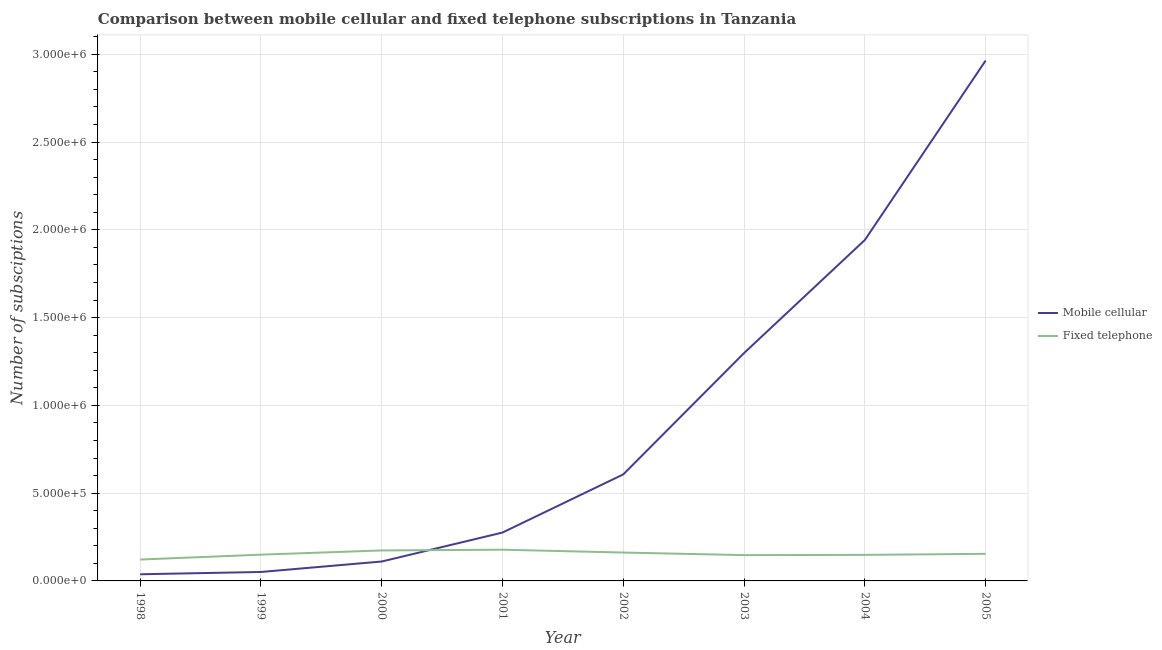How many different coloured lines are there?
Offer a very short reply. 2. Does the line corresponding to number of mobile cellular subscriptions intersect with the line corresponding to number of fixed telephone subscriptions?
Ensure brevity in your answer.  Yes. What is the number of mobile cellular subscriptions in 2004?
Give a very brief answer. 1.94e+06. Across all years, what is the maximum number of fixed telephone subscriptions?
Offer a very short reply. 1.78e+05. Across all years, what is the minimum number of fixed telephone subscriptions?
Your answer should be compact. 1.22e+05. In which year was the number of fixed telephone subscriptions maximum?
Your response must be concise. 2001. What is the total number of fixed telephone subscriptions in the graph?
Provide a short and direct response. 1.23e+06. What is the difference between the number of fixed telephone subscriptions in 1999 and that in 2003?
Your answer should be compact. 2605. What is the difference between the number of fixed telephone subscriptions in 2004 and the number of mobile cellular subscriptions in 1998?
Your response must be concise. 1.10e+05. What is the average number of mobile cellular subscriptions per year?
Provide a short and direct response. 9.11e+05. In the year 2002, what is the difference between the number of mobile cellular subscriptions and number of fixed telephone subscriptions?
Keep it short and to the point. 4.45e+05. In how many years, is the number of fixed telephone subscriptions greater than 1200000?
Make the answer very short. 0. What is the ratio of the number of fixed telephone subscriptions in 1999 to that in 2004?
Give a very brief answer. 1.01. Is the number of mobile cellular subscriptions in 2002 less than that in 2005?
Provide a succinct answer. Yes. What is the difference between the highest and the second highest number of mobile cellular subscriptions?
Provide a short and direct response. 1.02e+06. What is the difference between the highest and the lowest number of mobile cellular subscriptions?
Make the answer very short. 2.93e+06. Is the sum of the number of fixed telephone subscriptions in 1999 and 2001 greater than the maximum number of mobile cellular subscriptions across all years?
Your answer should be compact. No. Is the number of fixed telephone subscriptions strictly greater than the number of mobile cellular subscriptions over the years?
Your response must be concise. No. Is the number of mobile cellular subscriptions strictly less than the number of fixed telephone subscriptions over the years?
Make the answer very short. No. How many lines are there?
Ensure brevity in your answer.  2. How many years are there in the graph?
Provide a succinct answer. 8. Does the graph contain any zero values?
Keep it short and to the point. No. How are the legend labels stacked?
Your answer should be compact. Vertical. What is the title of the graph?
Keep it short and to the point. Comparison between mobile cellular and fixed telephone subscriptions in Tanzania. Does "National Tourists" appear as one of the legend labels in the graph?
Offer a terse response. No. What is the label or title of the X-axis?
Ensure brevity in your answer.  Year. What is the label or title of the Y-axis?
Your response must be concise. Number of subsciptions. What is the Number of subsciptions of Mobile cellular in 1998?
Offer a very short reply. 3.79e+04. What is the Number of subsciptions of Fixed telephone in 1998?
Ensure brevity in your answer.  1.22e+05. What is the Number of subsciptions of Mobile cellular in 1999?
Offer a terse response. 5.10e+04. What is the Number of subsciptions in Fixed telephone in 1999?
Offer a terse response. 1.50e+05. What is the Number of subsciptions of Mobile cellular in 2000?
Offer a terse response. 1.11e+05. What is the Number of subsciptions of Fixed telephone in 2000?
Give a very brief answer. 1.74e+05. What is the Number of subsciptions in Mobile cellular in 2001?
Provide a short and direct response. 2.76e+05. What is the Number of subsciptions in Fixed telephone in 2001?
Your answer should be compact. 1.78e+05. What is the Number of subsciptions in Mobile cellular in 2002?
Ensure brevity in your answer.  6.07e+05. What is the Number of subsciptions in Fixed telephone in 2002?
Ensure brevity in your answer.  1.62e+05. What is the Number of subsciptions in Mobile cellular in 2003?
Give a very brief answer. 1.30e+06. What is the Number of subsciptions of Fixed telephone in 2003?
Ensure brevity in your answer.  1.47e+05. What is the Number of subsciptions in Mobile cellular in 2004?
Make the answer very short. 1.94e+06. What is the Number of subsciptions of Fixed telephone in 2004?
Your response must be concise. 1.48e+05. What is the Number of subsciptions of Mobile cellular in 2005?
Offer a very short reply. 2.96e+06. What is the Number of subsciptions of Fixed telephone in 2005?
Offer a terse response. 1.54e+05. Across all years, what is the maximum Number of subsciptions of Mobile cellular?
Your answer should be very brief. 2.96e+06. Across all years, what is the maximum Number of subsciptions of Fixed telephone?
Make the answer very short. 1.78e+05. Across all years, what is the minimum Number of subsciptions in Mobile cellular?
Give a very brief answer. 3.79e+04. Across all years, what is the minimum Number of subsciptions in Fixed telephone?
Ensure brevity in your answer.  1.22e+05. What is the total Number of subsciptions in Mobile cellular in the graph?
Keep it short and to the point. 7.29e+06. What is the total Number of subsciptions in Fixed telephone in the graph?
Make the answer very short. 1.23e+06. What is the difference between the Number of subsciptions of Mobile cellular in 1998 and that in 1999?
Give a very brief answer. -1.30e+04. What is the difference between the Number of subsciptions of Fixed telephone in 1998 and that in 1999?
Keep it short and to the point. -2.78e+04. What is the difference between the Number of subsciptions of Mobile cellular in 1998 and that in 2000?
Your answer should be compact. -7.26e+04. What is the difference between the Number of subsciptions of Fixed telephone in 1998 and that in 2000?
Keep it short and to the point. -5.18e+04. What is the difference between the Number of subsciptions of Mobile cellular in 1998 and that in 2001?
Give a very brief answer. -2.38e+05. What is the difference between the Number of subsciptions of Fixed telephone in 1998 and that in 2001?
Provide a short and direct response. -5.60e+04. What is the difference between the Number of subsciptions of Mobile cellular in 1998 and that in 2002?
Offer a very short reply. -5.69e+05. What is the difference between the Number of subsciptions of Fixed telephone in 1998 and that in 2002?
Your answer should be very brief. -3.98e+04. What is the difference between the Number of subsciptions of Mobile cellular in 1998 and that in 2003?
Your response must be concise. -1.26e+06. What is the difference between the Number of subsciptions of Fixed telephone in 1998 and that in 2003?
Your answer should be compact. -2.52e+04. What is the difference between the Number of subsciptions in Mobile cellular in 1998 and that in 2004?
Keep it short and to the point. -1.90e+06. What is the difference between the Number of subsciptions in Fixed telephone in 1998 and that in 2004?
Make the answer very short. -2.66e+04. What is the difference between the Number of subsciptions of Mobile cellular in 1998 and that in 2005?
Make the answer very short. -2.93e+06. What is the difference between the Number of subsciptions in Fixed telephone in 1998 and that in 2005?
Offer a terse response. -3.26e+04. What is the difference between the Number of subsciptions of Mobile cellular in 1999 and that in 2000?
Keep it short and to the point. -5.96e+04. What is the difference between the Number of subsciptions of Fixed telephone in 1999 and that in 2000?
Give a very brief answer. -2.40e+04. What is the difference between the Number of subsciptions in Mobile cellular in 1999 and that in 2001?
Your answer should be compact. -2.25e+05. What is the difference between the Number of subsciptions in Fixed telephone in 1999 and that in 2001?
Offer a very short reply. -2.82e+04. What is the difference between the Number of subsciptions of Mobile cellular in 1999 and that in 2002?
Make the answer very short. -5.56e+05. What is the difference between the Number of subsciptions of Fixed telephone in 1999 and that in 2002?
Make the answer very short. -1.20e+04. What is the difference between the Number of subsciptions in Mobile cellular in 1999 and that in 2003?
Keep it short and to the point. -1.25e+06. What is the difference between the Number of subsciptions of Fixed telephone in 1999 and that in 2003?
Your response must be concise. 2605. What is the difference between the Number of subsciptions of Mobile cellular in 1999 and that in 2004?
Make the answer very short. -1.89e+06. What is the difference between the Number of subsciptions in Fixed telephone in 1999 and that in 2004?
Your response must be concise. 1251. What is the difference between the Number of subsciptions in Mobile cellular in 1999 and that in 2005?
Keep it short and to the point. -2.91e+06. What is the difference between the Number of subsciptions of Fixed telephone in 1999 and that in 2005?
Your response must be concise. -4749. What is the difference between the Number of subsciptions in Mobile cellular in 2000 and that in 2001?
Keep it short and to the point. -1.65e+05. What is the difference between the Number of subsciptions of Fixed telephone in 2000 and that in 2001?
Provide a succinct answer. -4211. What is the difference between the Number of subsciptions in Mobile cellular in 2000 and that in 2002?
Provide a succinct answer. -4.96e+05. What is the difference between the Number of subsciptions of Fixed telephone in 2000 and that in 2002?
Offer a very short reply. 1.20e+04. What is the difference between the Number of subsciptions of Mobile cellular in 2000 and that in 2003?
Give a very brief answer. -1.19e+06. What is the difference between the Number of subsciptions in Fixed telephone in 2000 and that in 2003?
Make the answer very short. 2.66e+04. What is the difference between the Number of subsciptions of Mobile cellular in 2000 and that in 2004?
Ensure brevity in your answer.  -1.83e+06. What is the difference between the Number of subsciptions in Fixed telephone in 2000 and that in 2004?
Provide a succinct answer. 2.52e+04. What is the difference between the Number of subsciptions of Mobile cellular in 2000 and that in 2005?
Offer a very short reply. -2.85e+06. What is the difference between the Number of subsciptions of Fixed telephone in 2000 and that in 2005?
Offer a very short reply. 1.92e+04. What is the difference between the Number of subsciptions in Mobile cellular in 2001 and that in 2002?
Ensure brevity in your answer.  -3.31e+05. What is the difference between the Number of subsciptions of Fixed telephone in 2001 and that in 2002?
Provide a succinct answer. 1.62e+04. What is the difference between the Number of subsciptions of Mobile cellular in 2001 and that in 2003?
Your response must be concise. -1.02e+06. What is the difference between the Number of subsciptions of Fixed telephone in 2001 and that in 2003?
Provide a short and direct response. 3.08e+04. What is the difference between the Number of subsciptions in Mobile cellular in 2001 and that in 2004?
Offer a terse response. -1.67e+06. What is the difference between the Number of subsciptions of Fixed telephone in 2001 and that in 2004?
Your response must be concise. 2.94e+04. What is the difference between the Number of subsciptions of Mobile cellular in 2001 and that in 2005?
Your answer should be compact. -2.69e+06. What is the difference between the Number of subsciptions of Fixed telephone in 2001 and that in 2005?
Offer a very short reply. 2.34e+04. What is the difference between the Number of subsciptions in Mobile cellular in 2002 and that in 2003?
Make the answer very short. -6.91e+05. What is the difference between the Number of subsciptions of Fixed telephone in 2002 and that in 2003?
Provide a short and direct response. 1.46e+04. What is the difference between the Number of subsciptions of Mobile cellular in 2002 and that in 2004?
Your answer should be compact. -1.34e+06. What is the difference between the Number of subsciptions of Fixed telephone in 2002 and that in 2004?
Offer a terse response. 1.32e+04. What is the difference between the Number of subsciptions in Mobile cellular in 2002 and that in 2005?
Your response must be concise. -2.36e+06. What is the difference between the Number of subsciptions in Fixed telephone in 2002 and that in 2005?
Give a very brief answer. 7230. What is the difference between the Number of subsciptions of Mobile cellular in 2003 and that in 2004?
Your answer should be very brief. -6.44e+05. What is the difference between the Number of subsciptions in Fixed telephone in 2003 and that in 2004?
Your answer should be compact. -1354. What is the difference between the Number of subsciptions in Mobile cellular in 2003 and that in 2005?
Provide a short and direct response. -1.67e+06. What is the difference between the Number of subsciptions of Fixed telephone in 2003 and that in 2005?
Give a very brief answer. -7354. What is the difference between the Number of subsciptions in Mobile cellular in 2004 and that in 2005?
Your answer should be compact. -1.02e+06. What is the difference between the Number of subsciptions in Fixed telephone in 2004 and that in 2005?
Your answer should be compact. -6000. What is the difference between the Number of subsciptions in Mobile cellular in 1998 and the Number of subsciptions in Fixed telephone in 1999?
Your answer should be compact. -1.12e+05. What is the difference between the Number of subsciptions in Mobile cellular in 1998 and the Number of subsciptions in Fixed telephone in 2000?
Ensure brevity in your answer.  -1.36e+05. What is the difference between the Number of subsciptions in Mobile cellular in 1998 and the Number of subsciptions in Fixed telephone in 2001?
Ensure brevity in your answer.  -1.40e+05. What is the difference between the Number of subsciptions in Mobile cellular in 1998 and the Number of subsciptions in Fixed telephone in 2002?
Offer a very short reply. -1.24e+05. What is the difference between the Number of subsciptions of Mobile cellular in 1998 and the Number of subsciptions of Fixed telephone in 2003?
Ensure brevity in your answer.  -1.09e+05. What is the difference between the Number of subsciptions of Mobile cellular in 1998 and the Number of subsciptions of Fixed telephone in 2004?
Offer a very short reply. -1.10e+05. What is the difference between the Number of subsciptions of Mobile cellular in 1998 and the Number of subsciptions of Fixed telephone in 2005?
Provide a short and direct response. -1.16e+05. What is the difference between the Number of subsciptions of Mobile cellular in 1999 and the Number of subsciptions of Fixed telephone in 2000?
Make the answer very short. -1.23e+05. What is the difference between the Number of subsciptions of Mobile cellular in 1999 and the Number of subsciptions of Fixed telephone in 2001?
Make the answer very short. -1.27e+05. What is the difference between the Number of subsciptions in Mobile cellular in 1999 and the Number of subsciptions in Fixed telephone in 2002?
Your answer should be very brief. -1.11e+05. What is the difference between the Number of subsciptions in Mobile cellular in 1999 and the Number of subsciptions in Fixed telephone in 2003?
Your response must be concise. -9.61e+04. What is the difference between the Number of subsciptions of Mobile cellular in 1999 and the Number of subsciptions of Fixed telephone in 2004?
Offer a terse response. -9.74e+04. What is the difference between the Number of subsciptions of Mobile cellular in 1999 and the Number of subsciptions of Fixed telephone in 2005?
Keep it short and to the point. -1.03e+05. What is the difference between the Number of subsciptions of Mobile cellular in 2000 and the Number of subsciptions of Fixed telephone in 2001?
Your answer should be very brief. -6.73e+04. What is the difference between the Number of subsciptions in Mobile cellular in 2000 and the Number of subsciptions in Fixed telephone in 2002?
Offer a terse response. -5.11e+04. What is the difference between the Number of subsciptions of Mobile cellular in 2000 and the Number of subsciptions of Fixed telephone in 2003?
Provide a succinct answer. -3.65e+04. What is the difference between the Number of subsciptions of Mobile cellular in 2000 and the Number of subsciptions of Fixed telephone in 2004?
Make the answer very short. -3.78e+04. What is the difference between the Number of subsciptions of Mobile cellular in 2000 and the Number of subsciptions of Fixed telephone in 2005?
Make the answer very short. -4.38e+04. What is the difference between the Number of subsciptions of Mobile cellular in 2001 and the Number of subsciptions of Fixed telephone in 2002?
Your response must be concise. 1.14e+05. What is the difference between the Number of subsciptions in Mobile cellular in 2001 and the Number of subsciptions in Fixed telephone in 2003?
Offer a terse response. 1.29e+05. What is the difference between the Number of subsciptions of Mobile cellular in 2001 and the Number of subsciptions of Fixed telephone in 2004?
Your response must be concise. 1.27e+05. What is the difference between the Number of subsciptions in Mobile cellular in 2001 and the Number of subsciptions in Fixed telephone in 2005?
Provide a short and direct response. 1.21e+05. What is the difference between the Number of subsciptions of Mobile cellular in 2002 and the Number of subsciptions of Fixed telephone in 2003?
Your response must be concise. 4.60e+05. What is the difference between the Number of subsciptions in Mobile cellular in 2002 and the Number of subsciptions in Fixed telephone in 2004?
Offer a terse response. 4.58e+05. What is the difference between the Number of subsciptions in Mobile cellular in 2002 and the Number of subsciptions in Fixed telephone in 2005?
Provide a short and direct response. 4.52e+05. What is the difference between the Number of subsciptions of Mobile cellular in 2003 and the Number of subsciptions of Fixed telephone in 2004?
Provide a succinct answer. 1.15e+06. What is the difference between the Number of subsciptions of Mobile cellular in 2003 and the Number of subsciptions of Fixed telephone in 2005?
Provide a succinct answer. 1.14e+06. What is the difference between the Number of subsciptions of Mobile cellular in 2004 and the Number of subsciptions of Fixed telephone in 2005?
Keep it short and to the point. 1.79e+06. What is the average Number of subsciptions in Mobile cellular per year?
Offer a terse response. 9.11e+05. What is the average Number of subsciptions in Fixed telephone per year?
Offer a very short reply. 1.54e+05. In the year 1998, what is the difference between the Number of subsciptions of Mobile cellular and Number of subsciptions of Fixed telephone?
Ensure brevity in your answer.  -8.38e+04. In the year 1999, what is the difference between the Number of subsciptions in Mobile cellular and Number of subsciptions in Fixed telephone?
Offer a very short reply. -9.87e+04. In the year 2000, what is the difference between the Number of subsciptions in Mobile cellular and Number of subsciptions in Fixed telephone?
Your answer should be compact. -6.31e+04. In the year 2001, what is the difference between the Number of subsciptions in Mobile cellular and Number of subsciptions in Fixed telephone?
Give a very brief answer. 9.78e+04. In the year 2002, what is the difference between the Number of subsciptions of Mobile cellular and Number of subsciptions of Fixed telephone?
Ensure brevity in your answer.  4.45e+05. In the year 2003, what is the difference between the Number of subsciptions of Mobile cellular and Number of subsciptions of Fixed telephone?
Ensure brevity in your answer.  1.15e+06. In the year 2004, what is the difference between the Number of subsciptions of Mobile cellular and Number of subsciptions of Fixed telephone?
Provide a short and direct response. 1.79e+06. In the year 2005, what is the difference between the Number of subsciptions in Mobile cellular and Number of subsciptions in Fixed telephone?
Your answer should be compact. 2.81e+06. What is the ratio of the Number of subsciptions in Mobile cellular in 1998 to that in 1999?
Provide a short and direct response. 0.74. What is the ratio of the Number of subsciptions of Fixed telephone in 1998 to that in 1999?
Ensure brevity in your answer.  0.81. What is the ratio of the Number of subsciptions in Mobile cellular in 1998 to that in 2000?
Provide a short and direct response. 0.34. What is the ratio of the Number of subsciptions in Fixed telephone in 1998 to that in 2000?
Offer a very short reply. 0.7. What is the ratio of the Number of subsciptions in Mobile cellular in 1998 to that in 2001?
Ensure brevity in your answer.  0.14. What is the ratio of the Number of subsciptions of Fixed telephone in 1998 to that in 2001?
Make the answer very short. 0.68. What is the ratio of the Number of subsciptions in Mobile cellular in 1998 to that in 2002?
Keep it short and to the point. 0.06. What is the ratio of the Number of subsciptions of Fixed telephone in 1998 to that in 2002?
Make the answer very short. 0.75. What is the ratio of the Number of subsciptions of Mobile cellular in 1998 to that in 2003?
Offer a very short reply. 0.03. What is the ratio of the Number of subsciptions in Fixed telephone in 1998 to that in 2003?
Give a very brief answer. 0.83. What is the ratio of the Number of subsciptions in Mobile cellular in 1998 to that in 2004?
Your answer should be very brief. 0.02. What is the ratio of the Number of subsciptions in Fixed telephone in 1998 to that in 2004?
Offer a very short reply. 0.82. What is the ratio of the Number of subsciptions of Mobile cellular in 1998 to that in 2005?
Your answer should be compact. 0.01. What is the ratio of the Number of subsciptions in Fixed telephone in 1998 to that in 2005?
Ensure brevity in your answer.  0.79. What is the ratio of the Number of subsciptions of Mobile cellular in 1999 to that in 2000?
Provide a succinct answer. 0.46. What is the ratio of the Number of subsciptions in Fixed telephone in 1999 to that in 2000?
Make the answer very short. 0.86. What is the ratio of the Number of subsciptions of Mobile cellular in 1999 to that in 2001?
Make the answer very short. 0.18. What is the ratio of the Number of subsciptions of Fixed telephone in 1999 to that in 2001?
Keep it short and to the point. 0.84. What is the ratio of the Number of subsciptions in Mobile cellular in 1999 to that in 2002?
Make the answer very short. 0.08. What is the ratio of the Number of subsciptions in Fixed telephone in 1999 to that in 2002?
Make the answer very short. 0.93. What is the ratio of the Number of subsciptions in Mobile cellular in 1999 to that in 2003?
Offer a terse response. 0.04. What is the ratio of the Number of subsciptions in Fixed telephone in 1999 to that in 2003?
Provide a short and direct response. 1.02. What is the ratio of the Number of subsciptions of Mobile cellular in 1999 to that in 2004?
Offer a very short reply. 0.03. What is the ratio of the Number of subsciptions of Fixed telephone in 1999 to that in 2004?
Make the answer very short. 1.01. What is the ratio of the Number of subsciptions in Mobile cellular in 1999 to that in 2005?
Ensure brevity in your answer.  0.02. What is the ratio of the Number of subsciptions of Fixed telephone in 1999 to that in 2005?
Provide a succinct answer. 0.97. What is the ratio of the Number of subsciptions of Mobile cellular in 2000 to that in 2001?
Your answer should be compact. 0.4. What is the ratio of the Number of subsciptions in Fixed telephone in 2000 to that in 2001?
Offer a terse response. 0.98. What is the ratio of the Number of subsciptions of Mobile cellular in 2000 to that in 2002?
Give a very brief answer. 0.18. What is the ratio of the Number of subsciptions of Fixed telephone in 2000 to that in 2002?
Your answer should be very brief. 1.07. What is the ratio of the Number of subsciptions in Mobile cellular in 2000 to that in 2003?
Offer a terse response. 0.09. What is the ratio of the Number of subsciptions of Fixed telephone in 2000 to that in 2003?
Make the answer very short. 1.18. What is the ratio of the Number of subsciptions in Mobile cellular in 2000 to that in 2004?
Your answer should be very brief. 0.06. What is the ratio of the Number of subsciptions in Fixed telephone in 2000 to that in 2004?
Your answer should be compact. 1.17. What is the ratio of the Number of subsciptions in Mobile cellular in 2000 to that in 2005?
Your answer should be compact. 0.04. What is the ratio of the Number of subsciptions in Fixed telephone in 2000 to that in 2005?
Give a very brief answer. 1.12. What is the ratio of the Number of subsciptions in Mobile cellular in 2001 to that in 2002?
Provide a succinct answer. 0.45. What is the ratio of the Number of subsciptions of Fixed telephone in 2001 to that in 2002?
Make the answer very short. 1.1. What is the ratio of the Number of subsciptions in Mobile cellular in 2001 to that in 2003?
Make the answer very short. 0.21. What is the ratio of the Number of subsciptions in Fixed telephone in 2001 to that in 2003?
Ensure brevity in your answer.  1.21. What is the ratio of the Number of subsciptions of Mobile cellular in 2001 to that in 2004?
Keep it short and to the point. 0.14. What is the ratio of the Number of subsciptions in Fixed telephone in 2001 to that in 2004?
Provide a succinct answer. 1.2. What is the ratio of the Number of subsciptions in Mobile cellular in 2001 to that in 2005?
Offer a very short reply. 0.09. What is the ratio of the Number of subsciptions in Fixed telephone in 2001 to that in 2005?
Offer a very short reply. 1.15. What is the ratio of the Number of subsciptions in Mobile cellular in 2002 to that in 2003?
Your response must be concise. 0.47. What is the ratio of the Number of subsciptions in Fixed telephone in 2002 to that in 2003?
Offer a very short reply. 1.1. What is the ratio of the Number of subsciptions in Mobile cellular in 2002 to that in 2004?
Your response must be concise. 0.31. What is the ratio of the Number of subsciptions in Fixed telephone in 2002 to that in 2004?
Make the answer very short. 1.09. What is the ratio of the Number of subsciptions of Mobile cellular in 2002 to that in 2005?
Your response must be concise. 0.2. What is the ratio of the Number of subsciptions in Fixed telephone in 2002 to that in 2005?
Give a very brief answer. 1.05. What is the ratio of the Number of subsciptions of Mobile cellular in 2003 to that in 2004?
Your response must be concise. 0.67. What is the ratio of the Number of subsciptions of Fixed telephone in 2003 to that in 2004?
Your answer should be compact. 0.99. What is the ratio of the Number of subsciptions of Mobile cellular in 2003 to that in 2005?
Your response must be concise. 0.44. What is the ratio of the Number of subsciptions of Fixed telephone in 2003 to that in 2005?
Provide a short and direct response. 0.95. What is the ratio of the Number of subsciptions in Mobile cellular in 2004 to that in 2005?
Your answer should be very brief. 0.66. What is the ratio of the Number of subsciptions in Fixed telephone in 2004 to that in 2005?
Make the answer very short. 0.96. What is the difference between the highest and the second highest Number of subsciptions of Mobile cellular?
Your answer should be compact. 1.02e+06. What is the difference between the highest and the second highest Number of subsciptions of Fixed telephone?
Keep it short and to the point. 4211. What is the difference between the highest and the lowest Number of subsciptions of Mobile cellular?
Your response must be concise. 2.93e+06. What is the difference between the highest and the lowest Number of subsciptions of Fixed telephone?
Make the answer very short. 5.60e+04. 